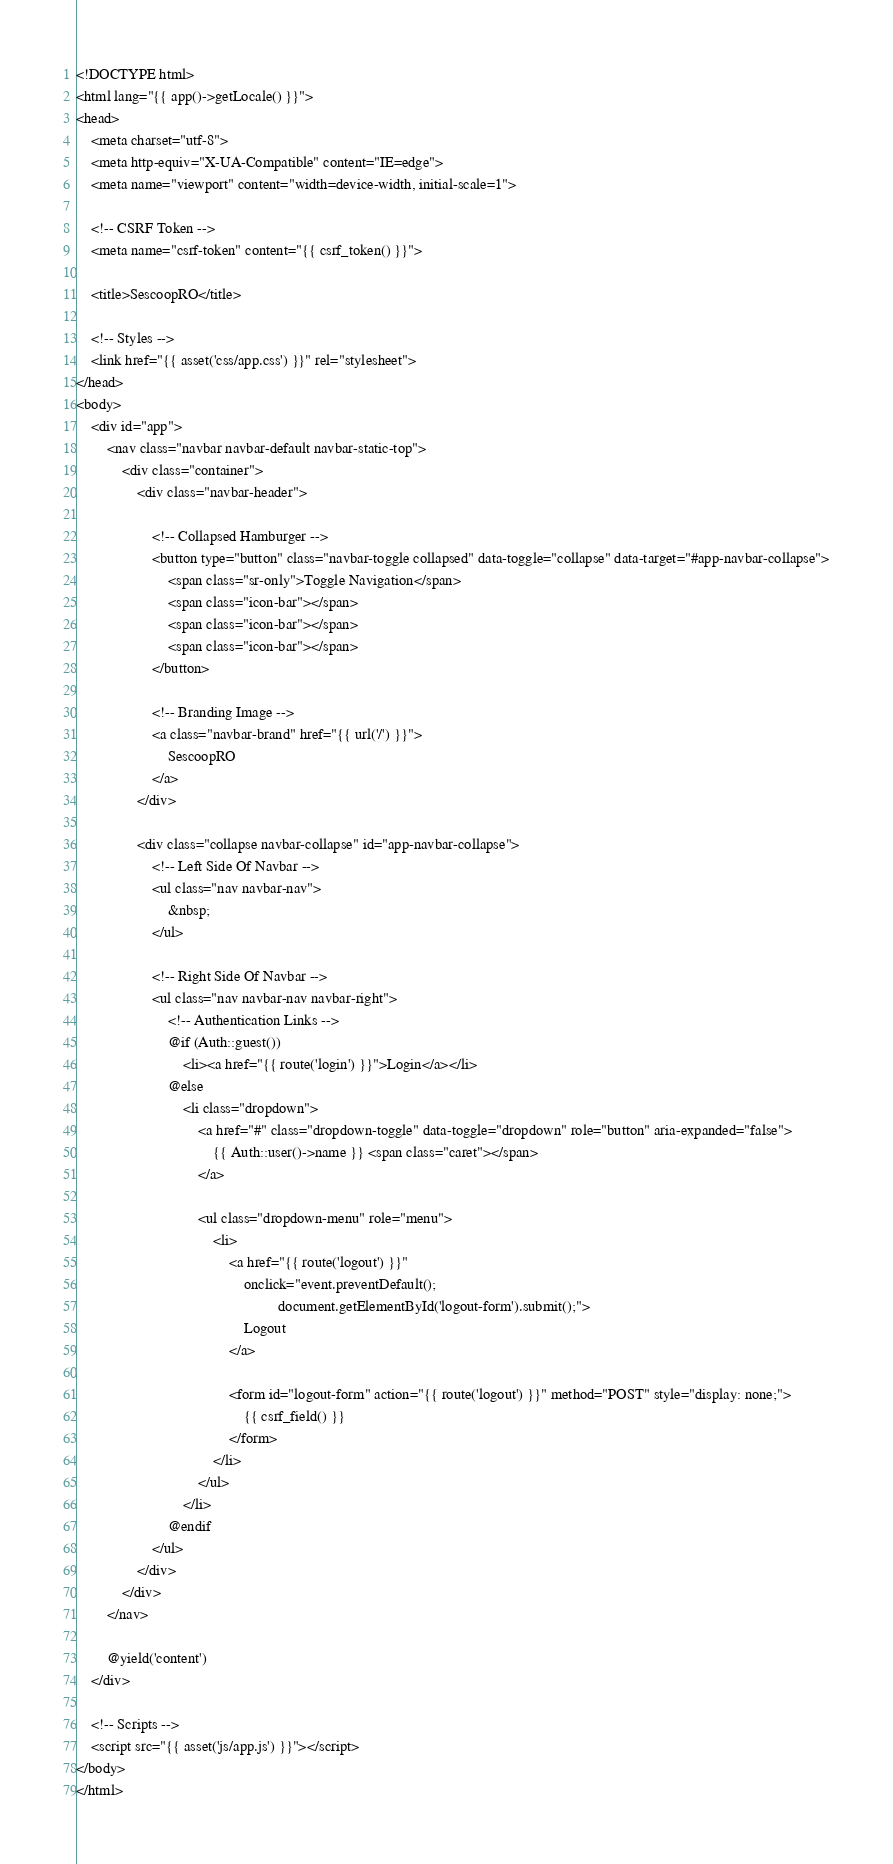<code> <loc_0><loc_0><loc_500><loc_500><_PHP_><!DOCTYPE html>
<html lang="{{ app()->getLocale() }}">
<head>
    <meta charset="utf-8">
    <meta http-equiv="X-UA-Compatible" content="IE=edge">
    <meta name="viewport" content="width=device-width, initial-scale=1">

    <!-- CSRF Token -->
    <meta name="csrf-token" content="{{ csrf_token() }}">

    <title>SescoopRO</title>

    <!-- Styles -->
    <link href="{{ asset('css/app.css') }}" rel="stylesheet">
</head>
<body>
    <div id="app">
        <nav class="navbar navbar-default navbar-static-top">
            <div class="container">
                <div class="navbar-header">

                    <!-- Collapsed Hamburger -->
                    <button type="button" class="navbar-toggle collapsed" data-toggle="collapse" data-target="#app-navbar-collapse">
                        <span class="sr-only">Toggle Navigation</span>
                        <span class="icon-bar"></span>
                        <span class="icon-bar"></span>
                        <span class="icon-bar"></span>
                    </button>

                    <!-- Branding Image -->
                    <a class="navbar-brand" href="{{ url('/') }}">
                        SescoopRO
                    </a>
                </div>

                <div class="collapse navbar-collapse" id="app-navbar-collapse">
                    <!-- Left Side Of Navbar -->
                    <ul class="nav navbar-nav">
                        &nbsp;
                    </ul>

                    <!-- Right Side Of Navbar -->
                    <ul class="nav navbar-nav navbar-right">
                        <!-- Authentication Links -->
                        @if (Auth::guest())
                            <li><a href="{{ route('login') }}">Login</a></li>
                        @else
                            <li class="dropdown">
                                <a href="#" class="dropdown-toggle" data-toggle="dropdown" role="button" aria-expanded="false">
                                    {{ Auth::user()->name }} <span class="caret"></span>
                                </a>

                                <ul class="dropdown-menu" role="menu">
                                    <li>
                                        <a href="{{ route('logout') }}"
                                            onclick="event.preventDefault();
                                                     document.getElementById('logout-form').submit();">
                                            Logout
                                        </a>

                                        <form id="logout-form" action="{{ route('logout') }}" method="POST" style="display: none;">
                                            {{ csrf_field() }}
                                        </form>
                                    </li>
                                </ul>
                            </li>
                        @endif
                    </ul>
                </div>
            </div>
        </nav>

        @yield('content')
    </div>

    <!-- Scripts -->
    <script src="{{ asset('js/app.js') }}"></script>
</body>
</html>
</code> 